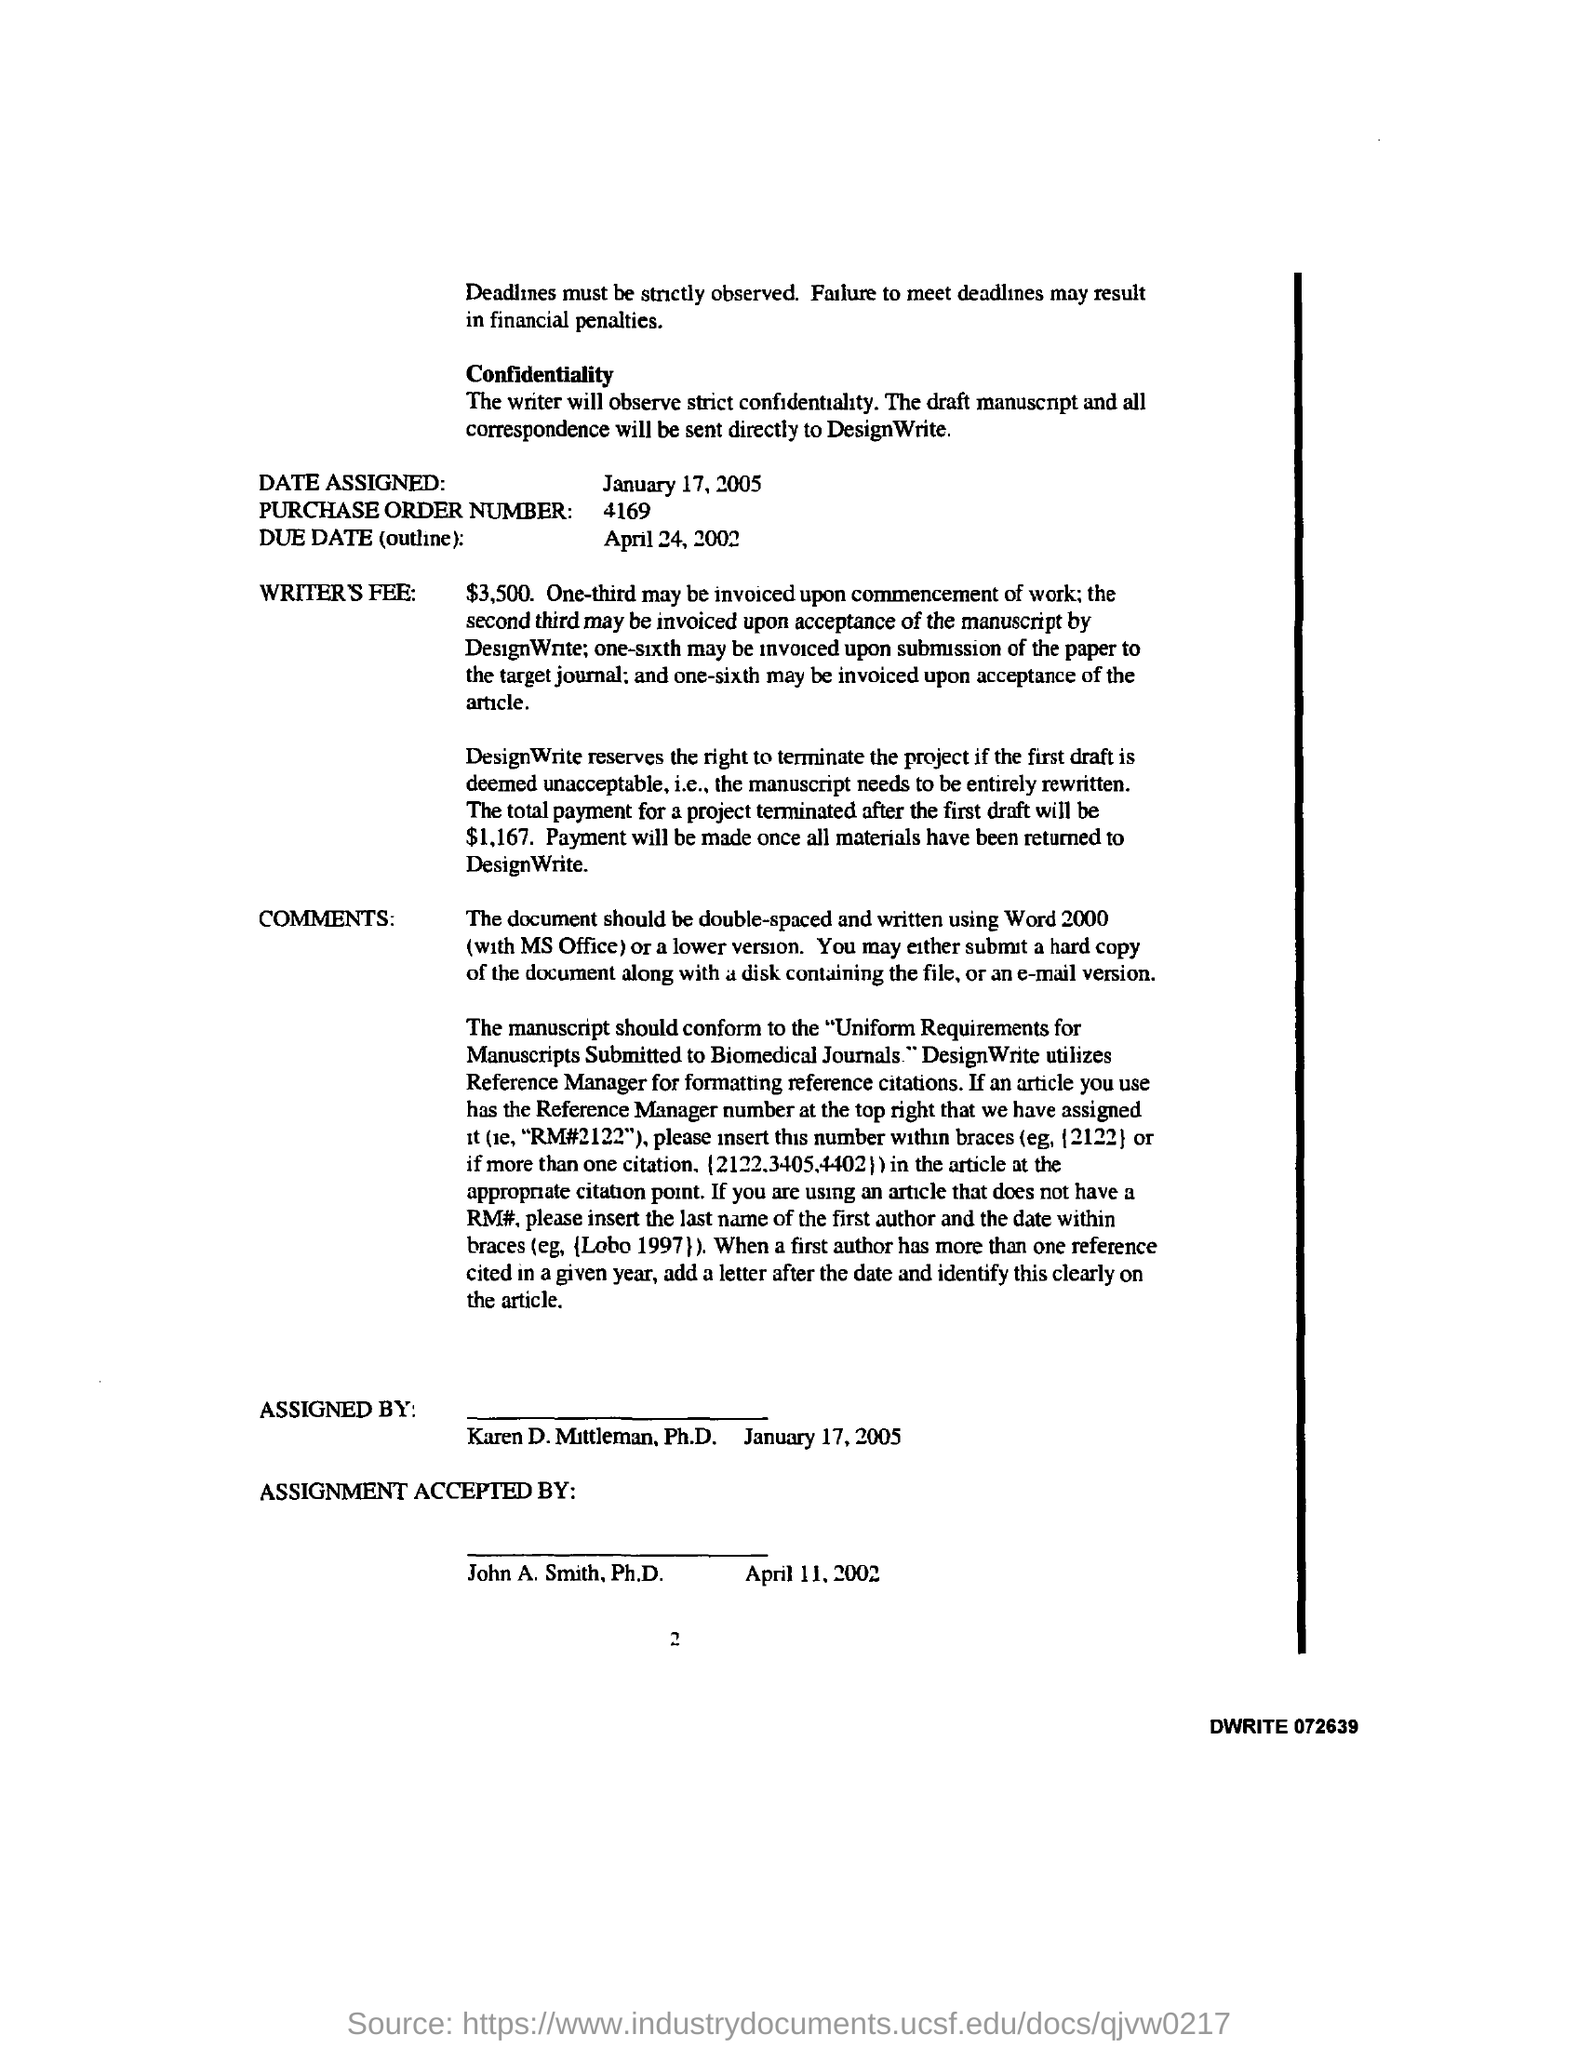What is the purchase order number ?
Offer a terse response. 4169. What is the due date (outline )?
Offer a very short reply. APRIL 24, 2002. This is assigned by whom ?
Your response must be concise. Karen D. Mittleman. What is the total payment for a project terminated after the first draft ?
Make the answer very short. $1,167. The design write utilizes whom for formatting reference citations ?
Keep it short and to the point. Reference manager. 